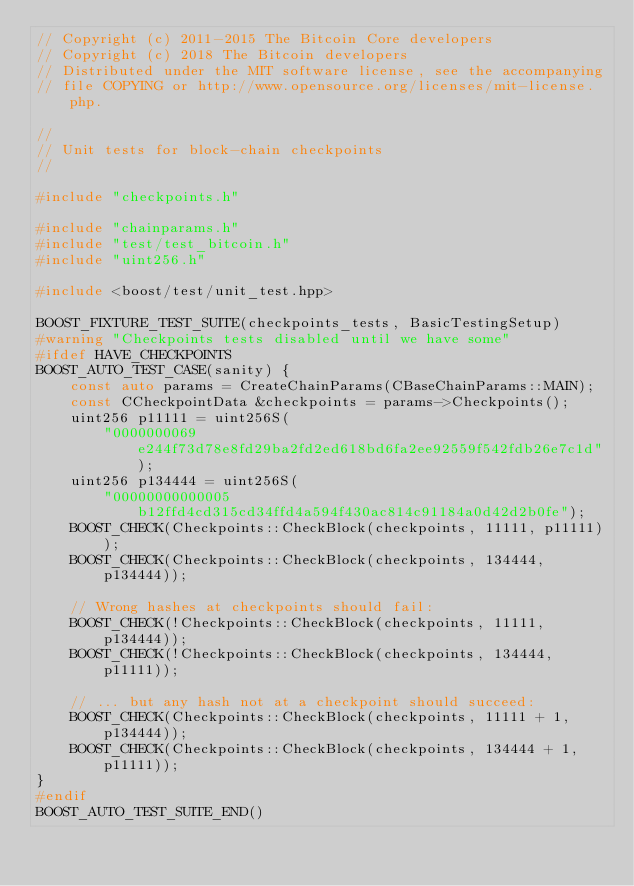<code> <loc_0><loc_0><loc_500><loc_500><_C++_>// Copyright (c) 2011-2015 The Bitcoin Core developers
// Copyright (c) 2018 The Bitcoin developers
// Distributed under the MIT software license, see the accompanying
// file COPYING or http://www.opensource.org/licenses/mit-license.php.

//
// Unit tests for block-chain checkpoints
//

#include "checkpoints.h"

#include "chainparams.h"
#include "test/test_bitcoin.h"
#include "uint256.h"

#include <boost/test/unit_test.hpp>

BOOST_FIXTURE_TEST_SUITE(checkpoints_tests, BasicTestingSetup)
#warning "Checkpoints tests disabled until we have some"
#ifdef HAVE_CHECKPOINTS
BOOST_AUTO_TEST_CASE(sanity) {
    const auto params = CreateChainParams(CBaseChainParams::MAIN);
    const CCheckpointData &checkpoints = params->Checkpoints();
    uint256 p11111 = uint256S(
        "0000000069e244f73d78e8fd29ba2fd2ed618bd6fa2ee92559f542fdb26e7c1d");
    uint256 p134444 = uint256S(
        "00000000000005b12ffd4cd315cd34ffd4a594f430ac814c91184a0d42d2b0fe");
    BOOST_CHECK(Checkpoints::CheckBlock(checkpoints, 11111, p11111));
    BOOST_CHECK(Checkpoints::CheckBlock(checkpoints, 134444, p134444));

    // Wrong hashes at checkpoints should fail:
    BOOST_CHECK(!Checkpoints::CheckBlock(checkpoints, 11111, p134444));
    BOOST_CHECK(!Checkpoints::CheckBlock(checkpoints, 134444, p11111));

    // ... but any hash not at a checkpoint should succeed:
    BOOST_CHECK(Checkpoints::CheckBlock(checkpoints, 11111 + 1, p134444));
    BOOST_CHECK(Checkpoints::CheckBlock(checkpoints, 134444 + 1, p11111));
}
#endif
BOOST_AUTO_TEST_SUITE_END()
</code> 